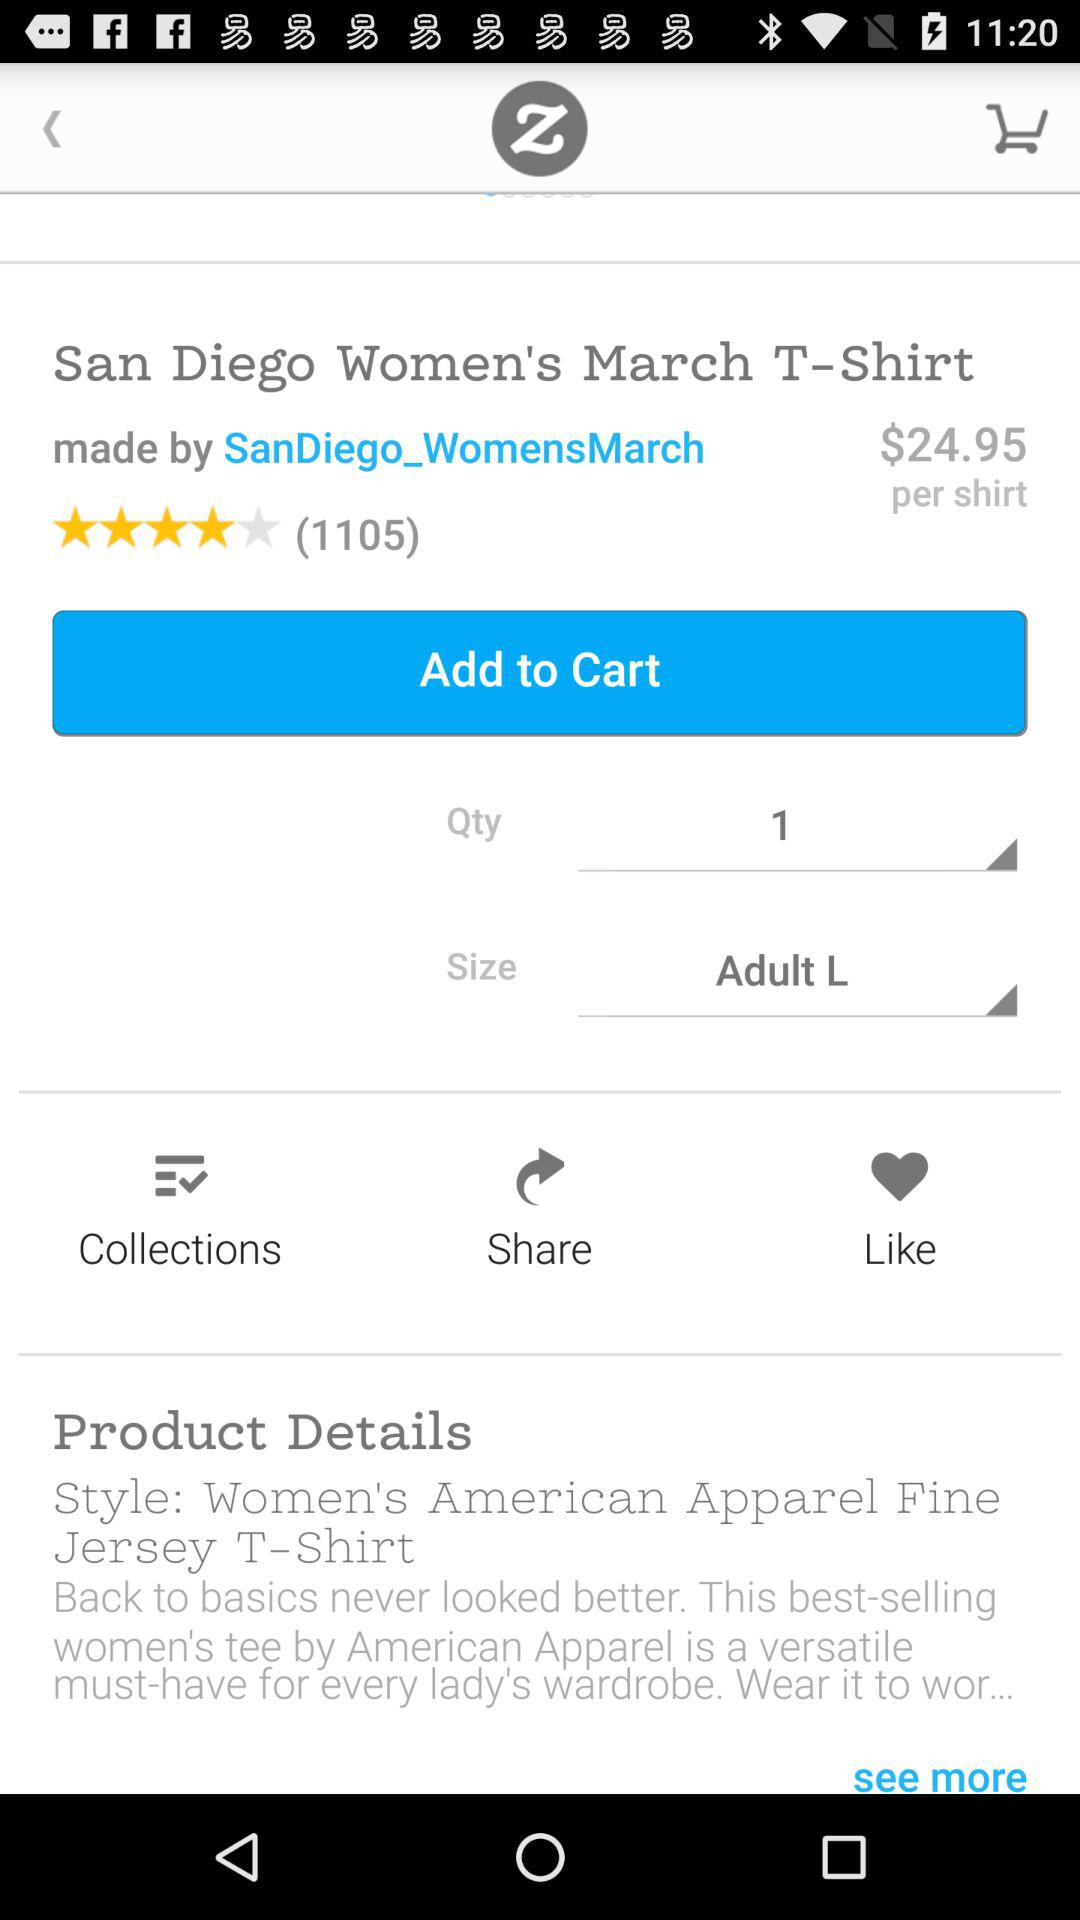What is the selected size? The selected size is "Adult L". 